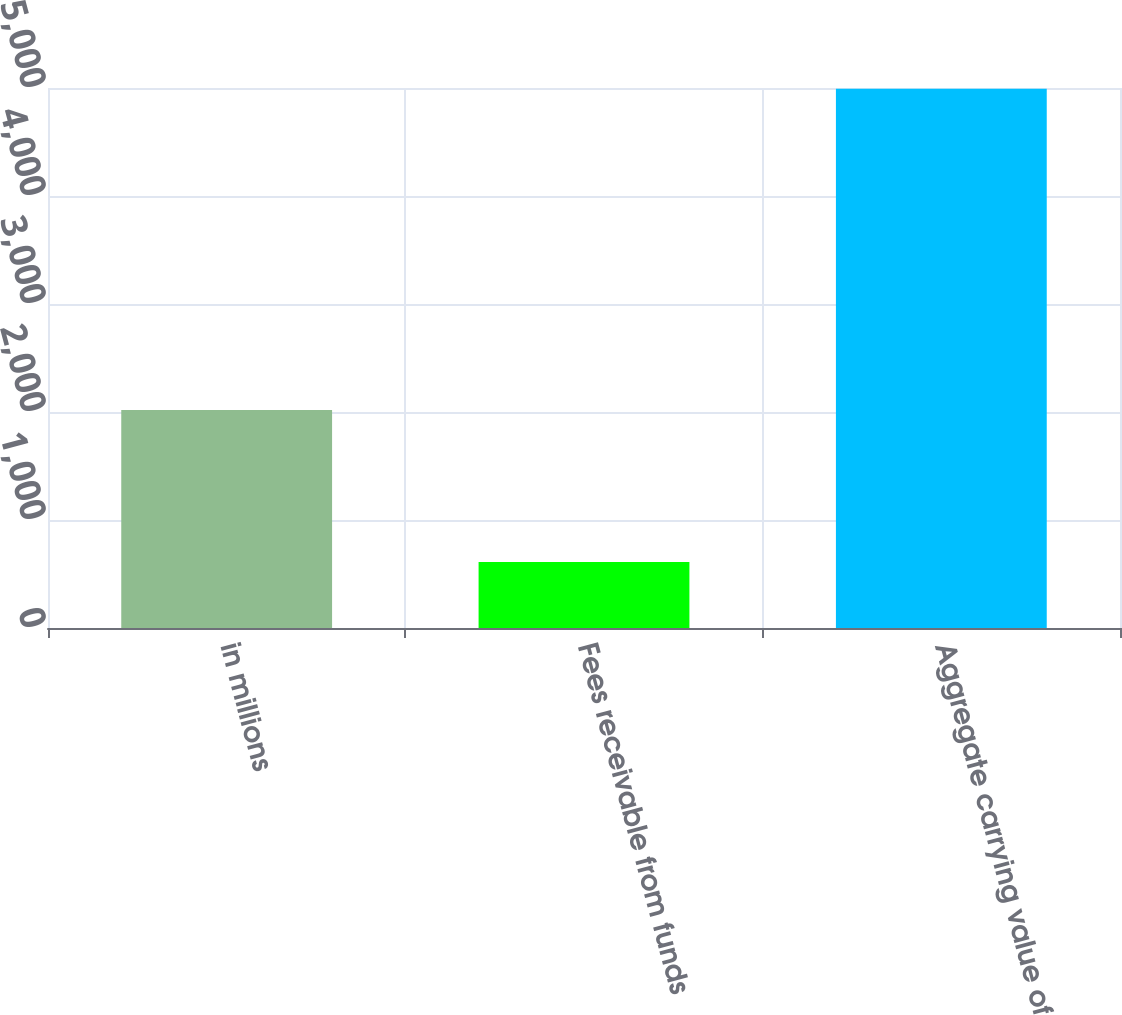Convert chart. <chart><loc_0><loc_0><loc_500><loc_500><bar_chart><fcel>in millions<fcel>Fees receivable from funds<fcel>Aggregate carrying value of<nl><fcel>2018<fcel>610<fcel>4994<nl></chart> 